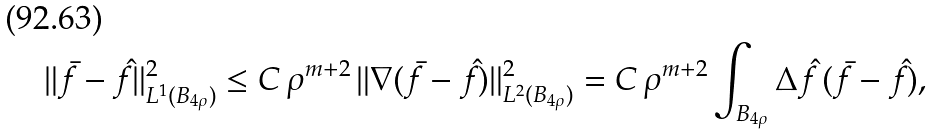<formula> <loc_0><loc_0><loc_500><loc_500>\| \bar { f } - \hat { f } \| _ { L ^ { 1 } ( B _ { 4 \rho } ) } ^ { 2 } \leq C \, \rho ^ { m + 2 } \, \| \nabla ( \bar { f } - \hat { f } ) \| _ { L ^ { 2 } ( B _ { 4 \rho } ) } ^ { 2 } = C \, \rho ^ { m + 2 } \int _ { B _ { 4 \rho } } \Delta \hat { f } \, ( \bar { f } - \hat { f } ) ,</formula> 